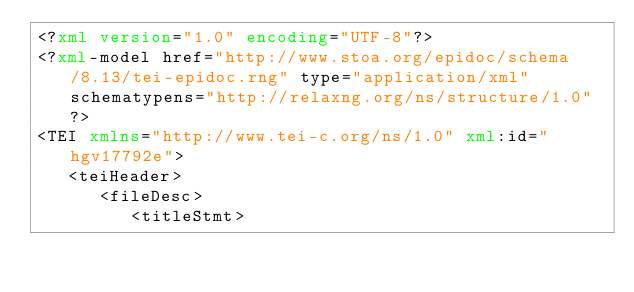<code> <loc_0><loc_0><loc_500><loc_500><_XML_><?xml version="1.0" encoding="UTF-8"?>
<?xml-model href="http://www.stoa.org/epidoc/schema/8.13/tei-epidoc.rng" type="application/xml" schematypens="http://relaxng.org/ns/structure/1.0"?>
<TEI xmlns="http://www.tei-c.org/ns/1.0" xml:id="hgv17792e">
   <teiHeader>
      <fileDesc>
         <titleStmt></code> 